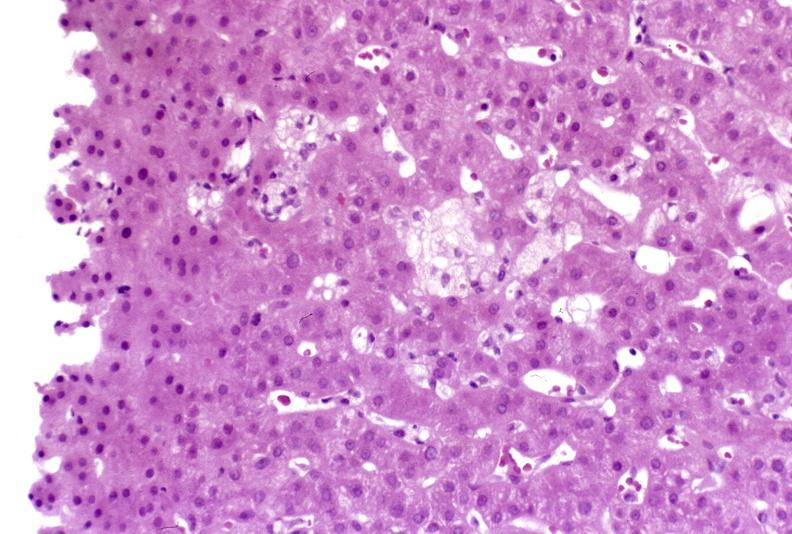s adrenal of premature 30 week gestation gram infant lesion present?
Answer the question using a single word or phrase. No 